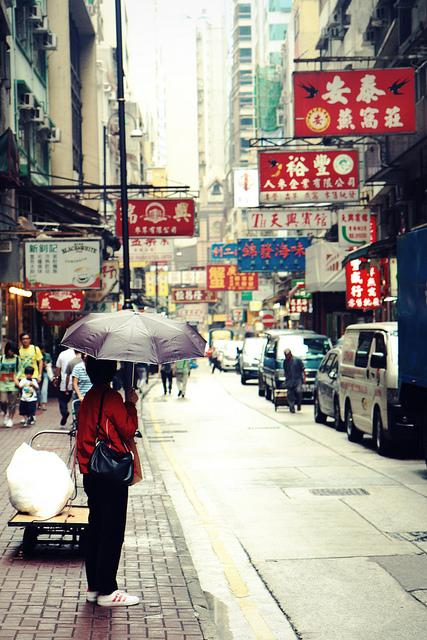Who is the maker of the white shoes? Please explain your reasoning. adidas. A person is wearing shoes with three stripes. the logo for adidas has three stripes. 